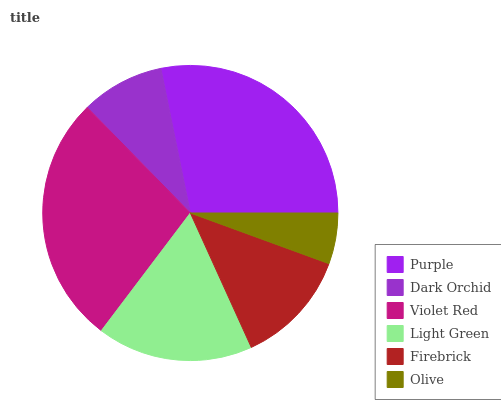Is Olive the minimum?
Answer yes or no. Yes. Is Purple the maximum?
Answer yes or no. Yes. Is Dark Orchid the minimum?
Answer yes or no. No. Is Dark Orchid the maximum?
Answer yes or no. No. Is Purple greater than Dark Orchid?
Answer yes or no. Yes. Is Dark Orchid less than Purple?
Answer yes or no. Yes. Is Dark Orchid greater than Purple?
Answer yes or no. No. Is Purple less than Dark Orchid?
Answer yes or no. No. Is Light Green the high median?
Answer yes or no. Yes. Is Firebrick the low median?
Answer yes or no. Yes. Is Violet Red the high median?
Answer yes or no. No. Is Violet Red the low median?
Answer yes or no. No. 